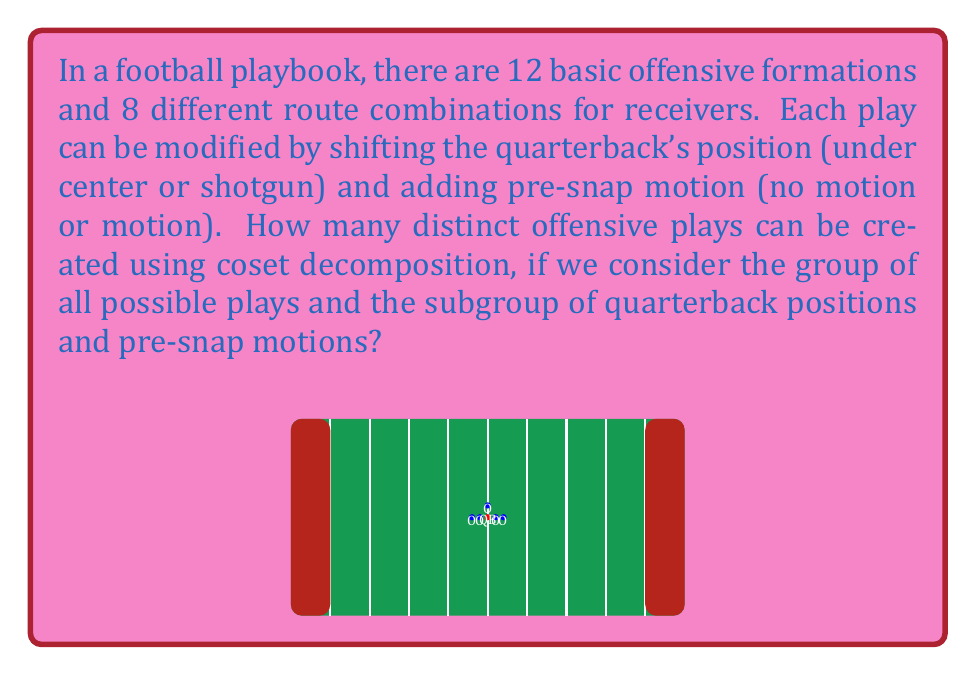Solve this math problem. To solve this problem using coset decomposition, let's follow these steps:

1) First, let's define our groups:
   - Let $G$ be the group of all possible plays
   - Let $H$ be the subgroup of quarterback positions and pre-snap motions

2) The order of $H$ is:
   $|H| = 2 \times 2 = 4$ (2 QB positions × 2 motion options)

3) The total number of elements in $G$ is:
   $|G| = 12 \times 8 \times 2 \times 2 = 384$ (12 formations × 8 route combinations × 2 QB positions × 2 motion options)

4) By the Lagrange theorem, we know that the number of distinct cosets is equal to the index of $H$ in $G$, which is:

   $[G:H] = \frac{|G|}{|H|} = \frac{384}{4} = 96$

5) Each coset represents a distinct play when we consider the variations in formations and route combinations, but ignore the specific QB position and pre-snap motion.

6) Therefore, the number of distinct offensive plays using coset decomposition is equal to the number of cosets, which is 96.

This approach effectively groups plays that differ only by QB position and pre-snap motion into the same coset, giving us a count of fundamentally different plays.
Answer: 96 distinct plays 